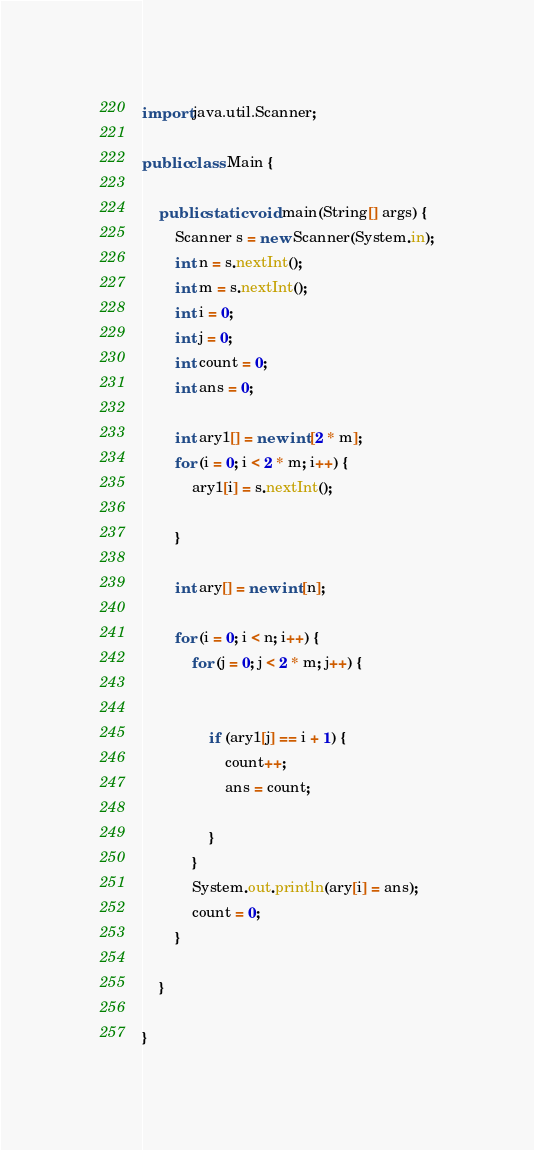Convert code to text. <code><loc_0><loc_0><loc_500><loc_500><_Java_>import java.util.Scanner;

public class Main {

	public static void main(String[] args) {
		Scanner s = new Scanner(System.in);
		int n = s.nextInt();
		int m = s.nextInt();
		int i = 0;
		int j = 0;
		int count = 0;
		int ans = 0;

		int ary1[] = new int[2 * m];
		for (i = 0; i < 2 * m; i++) {
			ary1[i] = s.nextInt();
			
		}

		int ary[] = new int[n];

		for (i = 0; i < n; i++) {
			for (j = 0; j < 2 * m; j++) {


				if (ary1[j] == i + 1) {
					count++;
					ans = count;

				}
			}
			System.out.println(ary[i] = ans);
			count = 0;
		}

	}

}</code> 